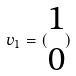<formula> <loc_0><loc_0><loc_500><loc_500>v _ { 1 } = ( \begin{matrix} 1 \\ 0 \end{matrix} )</formula> 